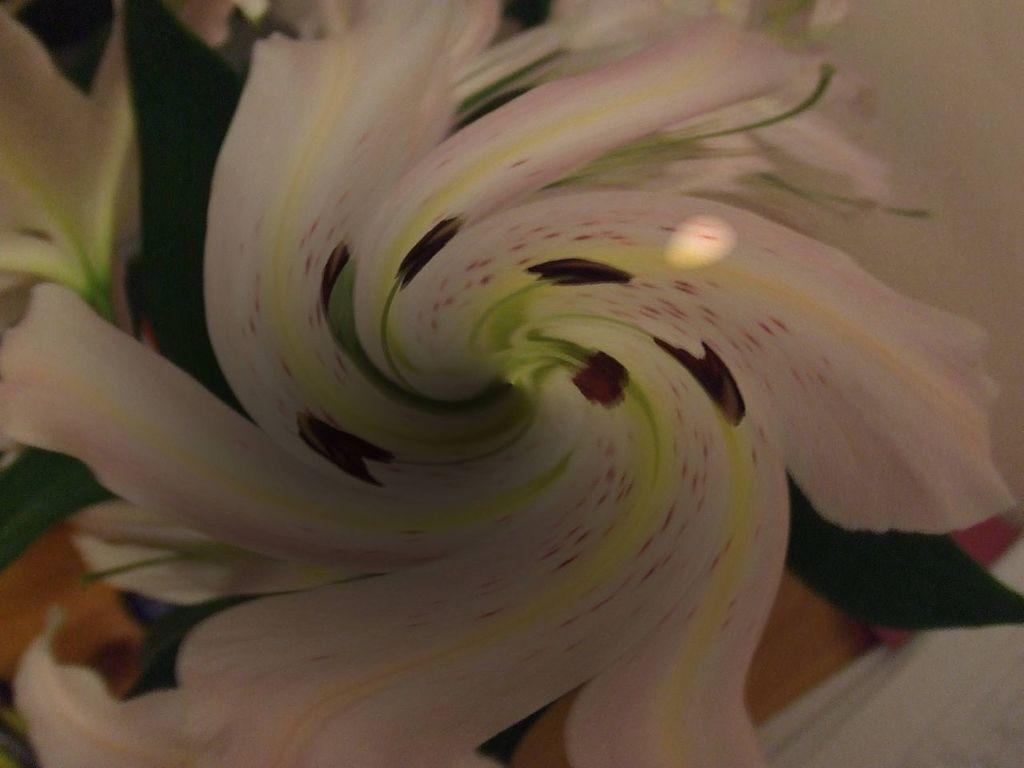Describe this image in one or two sentences. As we can see in the image there is a white color flower. 